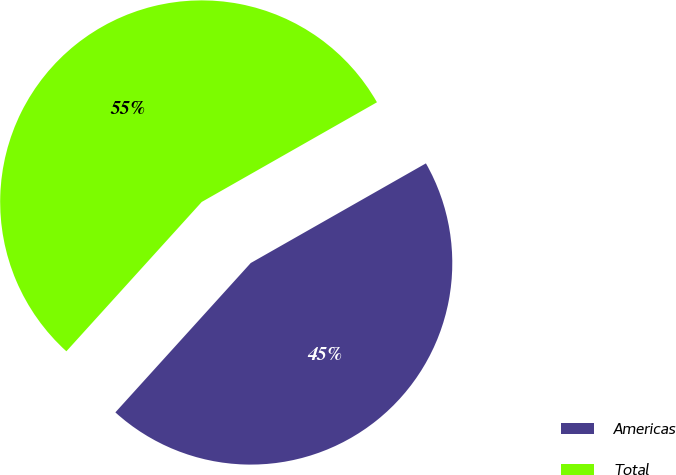Convert chart. <chart><loc_0><loc_0><loc_500><loc_500><pie_chart><fcel>Americas<fcel>Total<nl><fcel>44.95%<fcel>55.05%<nl></chart> 